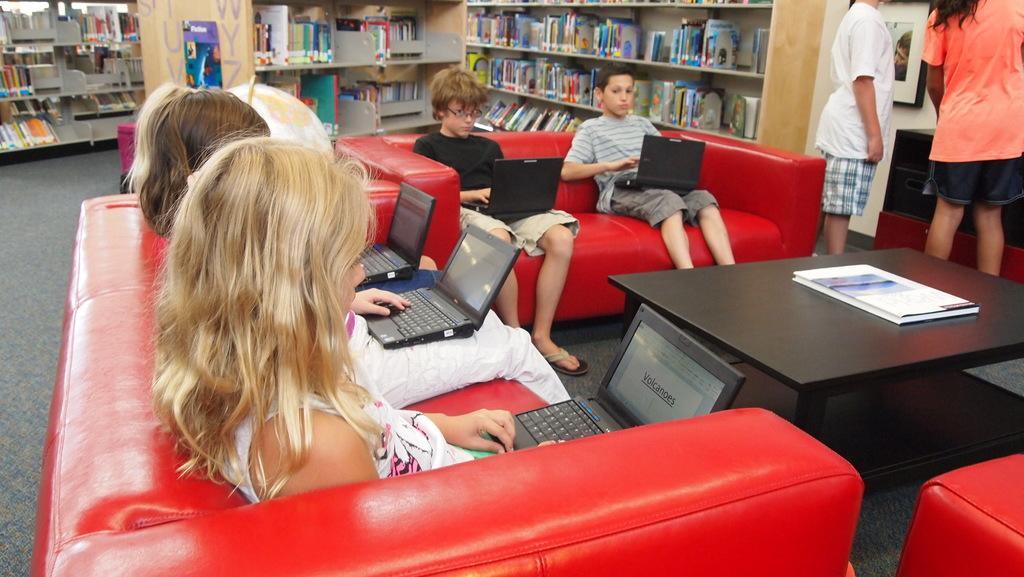Can you describe this image briefly? On the background we can see racks where books are arranged in a sequence manner. Here on a red colour sofa we can see girls and boys sitting and working on a laptop. On the table we can see a book. We can see two persons standing here near to the sofa. This is a sofa. 